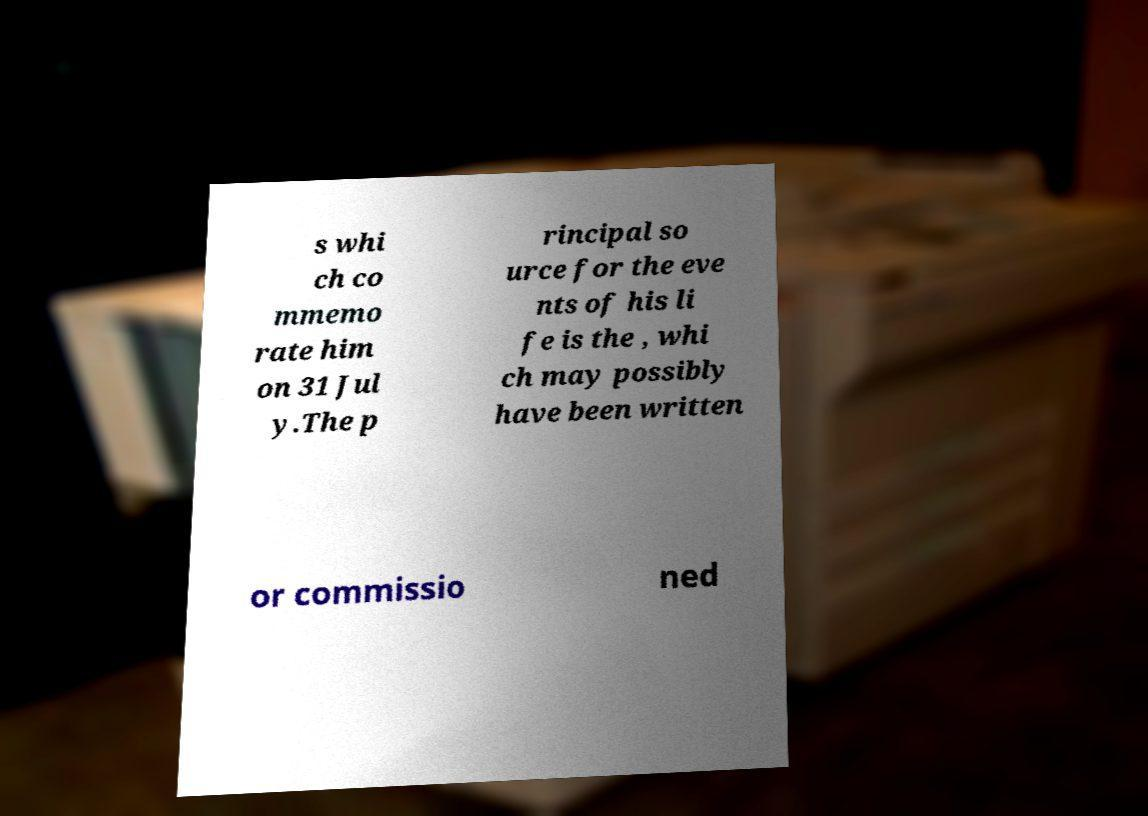For documentation purposes, I need the text within this image transcribed. Could you provide that? s whi ch co mmemo rate him on 31 Jul y.The p rincipal so urce for the eve nts of his li fe is the , whi ch may possibly have been written or commissio ned 